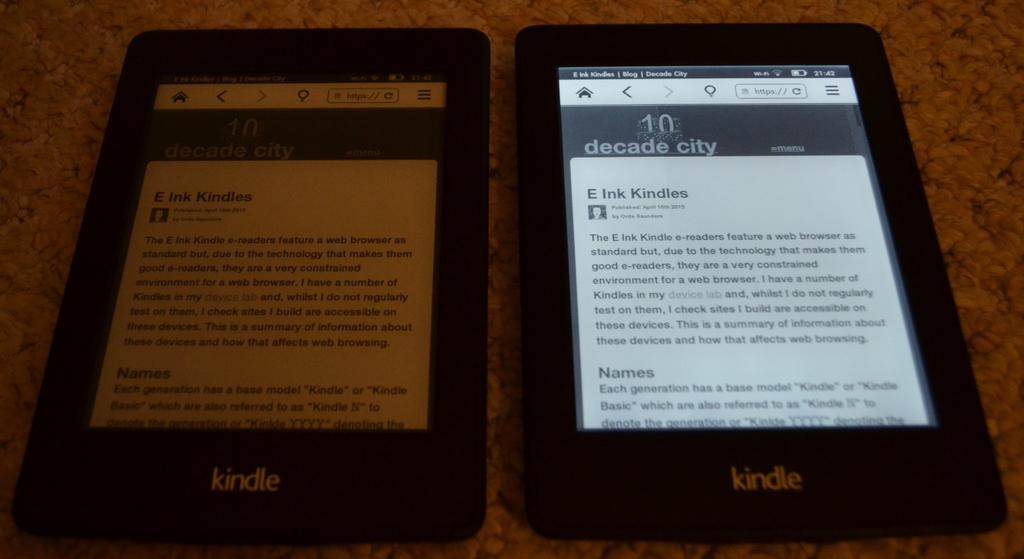How many electronic devices can be seen in the image? There are two electronic devices in the image. What is the color of the surface beneath the electronic devices? The surface beneath the electronic devices is brown in color. What type of lettuce is being served for breakfast in the image? There is no lettuce or breakfast depicted in the image; it only features two electronic devices on a brown surface. 